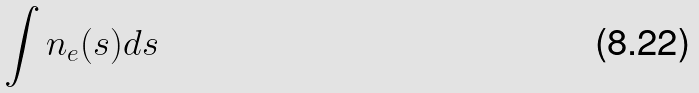<formula> <loc_0><loc_0><loc_500><loc_500>\int n _ { e } ( s ) d s</formula> 